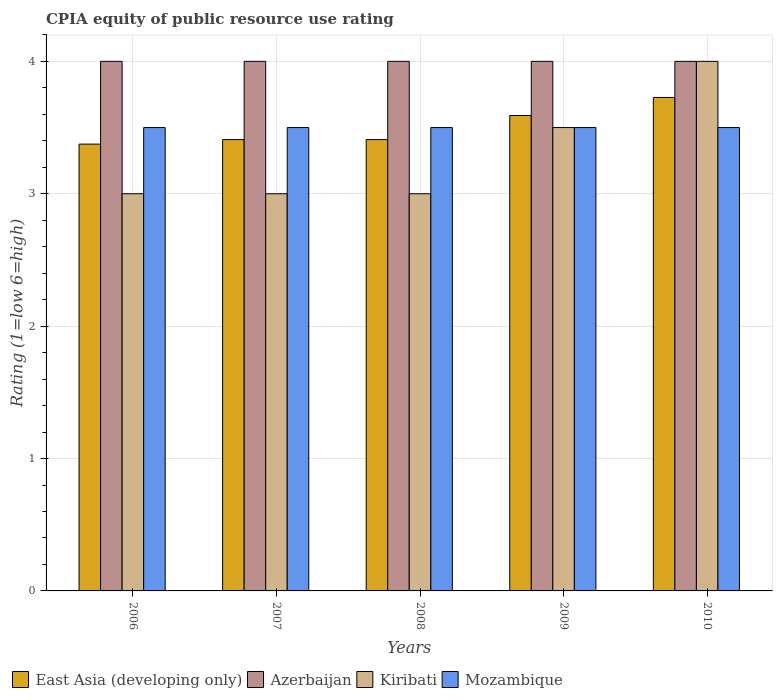How many groups of bars are there?
Give a very brief answer. 5. Are the number of bars per tick equal to the number of legend labels?
Give a very brief answer. Yes. Are the number of bars on each tick of the X-axis equal?
Your answer should be compact. Yes. How many bars are there on the 5th tick from the right?
Give a very brief answer. 4. Across all years, what is the maximum CPIA rating in East Asia (developing only)?
Offer a very short reply. 3.73. Across all years, what is the minimum CPIA rating in Azerbaijan?
Offer a very short reply. 4. In which year was the CPIA rating in East Asia (developing only) maximum?
Your answer should be compact. 2010. What is the total CPIA rating in East Asia (developing only) in the graph?
Ensure brevity in your answer.  17.51. What is the average CPIA rating in Azerbaijan per year?
Keep it short and to the point. 4. In the year 2009, what is the difference between the CPIA rating in East Asia (developing only) and CPIA rating in Mozambique?
Your response must be concise. 0.09. In how many years, is the CPIA rating in Kiribati greater than 2.2?
Make the answer very short. 5. Is the difference between the CPIA rating in East Asia (developing only) in 2008 and 2009 greater than the difference between the CPIA rating in Mozambique in 2008 and 2009?
Provide a short and direct response. No. What is the difference between the highest and the second highest CPIA rating in East Asia (developing only)?
Ensure brevity in your answer.  0.14. What is the difference between the highest and the lowest CPIA rating in Azerbaijan?
Your answer should be very brief. 0. Is the sum of the CPIA rating in Azerbaijan in 2006 and 2007 greater than the maximum CPIA rating in Mozambique across all years?
Offer a terse response. Yes. What does the 2nd bar from the left in 2007 represents?
Your answer should be compact. Azerbaijan. What does the 3rd bar from the right in 2007 represents?
Your answer should be compact. Azerbaijan. Is it the case that in every year, the sum of the CPIA rating in Mozambique and CPIA rating in Kiribati is greater than the CPIA rating in East Asia (developing only)?
Your answer should be compact. Yes. How many years are there in the graph?
Your response must be concise. 5. Does the graph contain grids?
Keep it short and to the point. Yes. Where does the legend appear in the graph?
Give a very brief answer. Bottom left. How are the legend labels stacked?
Provide a succinct answer. Horizontal. What is the title of the graph?
Your answer should be compact. CPIA equity of public resource use rating. Does "South Sudan" appear as one of the legend labels in the graph?
Provide a succinct answer. No. What is the label or title of the X-axis?
Offer a very short reply. Years. What is the label or title of the Y-axis?
Provide a short and direct response. Rating (1=low 6=high). What is the Rating (1=low 6=high) in East Asia (developing only) in 2006?
Your answer should be very brief. 3.38. What is the Rating (1=low 6=high) of Azerbaijan in 2006?
Your answer should be compact. 4. What is the Rating (1=low 6=high) of Kiribati in 2006?
Your response must be concise. 3. What is the Rating (1=low 6=high) in East Asia (developing only) in 2007?
Keep it short and to the point. 3.41. What is the Rating (1=low 6=high) of Azerbaijan in 2007?
Offer a terse response. 4. What is the Rating (1=low 6=high) of Mozambique in 2007?
Offer a terse response. 3.5. What is the Rating (1=low 6=high) in East Asia (developing only) in 2008?
Keep it short and to the point. 3.41. What is the Rating (1=low 6=high) of East Asia (developing only) in 2009?
Offer a very short reply. 3.59. What is the Rating (1=low 6=high) in Azerbaijan in 2009?
Provide a succinct answer. 4. What is the Rating (1=low 6=high) of Kiribati in 2009?
Ensure brevity in your answer.  3.5. What is the Rating (1=low 6=high) of Mozambique in 2009?
Offer a terse response. 3.5. What is the Rating (1=low 6=high) of East Asia (developing only) in 2010?
Ensure brevity in your answer.  3.73. What is the Rating (1=low 6=high) in Azerbaijan in 2010?
Make the answer very short. 4. Across all years, what is the maximum Rating (1=low 6=high) of East Asia (developing only)?
Your answer should be compact. 3.73. Across all years, what is the maximum Rating (1=low 6=high) in Kiribati?
Your response must be concise. 4. Across all years, what is the minimum Rating (1=low 6=high) in East Asia (developing only)?
Ensure brevity in your answer.  3.38. Across all years, what is the minimum Rating (1=low 6=high) of Azerbaijan?
Ensure brevity in your answer.  4. Across all years, what is the minimum Rating (1=low 6=high) of Kiribati?
Your answer should be compact. 3. What is the total Rating (1=low 6=high) in East Asia (developing only) in the graph?
Provide a succinct answer. 17.51. What is the total Rating (1=low 6=high) of Kiribati in the graph?
Your response must be concise. 16.5. What is the difference between the Rating (1=low 6=high) in East Asia (developing only) in 2006 and that in 2007?
Make the answer very short. -0.03. What is the difference between the Rating (1=low 6=high) in East Asia (developing only) in 2006 and that in 2008?
Your answer should be very brief. -0.03. What is the difference between the Rating (1=low 6=high) in East Asia (developing only) in 2006 and that in 2009?
Ensure brevity in your answer.  -0.22. What is the difference between the Rating (1=low 6=high) in Mozambique in 2006 and that in 2009?
Your answer should be very brief. 0. What is the difference between the Rating (1=low 6=high) of East Asia (developing only) in 2006 and that in 2010?
Make the answer very short. -0.35. What is the difference between the Rating (1=low 6=high) in Kiribati in 2006 and that in 2010?
Ensure brevity in your answer.  -1. What is the difference between the Rating (1=low 6=high) in Mozambique in 2006 and that in 2010?
Ensure brevity in your answer.  0. What is the difference between the Rating (1=low 6=high) of East Asia (developing only) in 2007 and that in 2008?
Keep it short and to the point. 0. What is the difference between the Rating (1=low 6=high) of East Asia (developing only) in 2007 and that in 2009?
Give a very brief answer. -0.18. What is the difference between the Rating (1=low 6=high) in Azerbaijan in 2007 and that in 2009?
Keep it short and to the point. 0. What is the difference between the Rating (1=low 6=high) in Kiribati in 2007 and that in 2009?
Provide a short and direct response. -0.5. What is the difference between the Rating (1=low 6=high) of Mozambique in 2007 and that in 2009?
Your answer should be compact. 0. What is the difference between the Rating (1=low 6=high) of East Asia (developing only) in 2007 and that in 2010?
Make the answer very short. -0.32. What is the difference between the Rating (1=low 6=high) in Azerbaijan in 2007 and that in 2010?
Provide a short and direct response. 0. What is the difference between the Rating (1=low 6=high) in Kiribati in 2007 and that in 2010?
Your answer should be compact. -1. What is the difference between the Rating (1=low 6=high) in Mozambique in 2007 and that in 2010?
Make the answer very short. 0. What is the difference between the Rating (1=low 6=high) of East Asia (developing only) in 2008 and that in 2009?
Give a very brief answer. -0.18. What is the difference between the Rating (1=low 6=high) in Mozambique in 2008 and that in 2009?
Make the answer very short. 0. What is the difference between the Rating (1=low 6=high) in East Asia (developing only) in 2008 and that in 2010?
Ensure brevity in your answer.  -0.32. What is the difference between the Rating (1=low 6=high) in Mozambique in 2008 and that in 2010?
Keep it short and to the point. 0. What is the difference between the Rating (1=low 6=high) in East Asia (developing only) in 2009 and that in 2010?
Provide a short and direct response. -0.14. What is the difference between the Rating (1=low 6=high) of Kiribati in 2009 and that in 2010?
Keep it short and to the point. -0.5. What is the difference between the Rating (1=low 6=high) in East Asia (developing only) in 2006 and the Rating (1=low 6=high) in Azerbaijan in 2007?
Provide a succinct answer. -0.62. What is the difference between the Rating (1=low 6=high) in East Asia (developing only) in 2006 and the Rating (1=low 6=high) in Kiribati in 2007?
Keep it short and to the point. 0.38. What is the difference between the Rating (1=low 6=high) in East Asia (developing only) in 2006 and the Rating (1=low 6=high) in Mozambique in 2007?
Provide a succinct answer. -0.12. What is the difference between the Rating (1=low 6=high) of Azerbaijan in 2006 and the Rating (1=low 6=high) of Mozambique in 2007?
Your answer should be compact. 0.5. What is the difference between the Rating (1=low 6=high) of East Asia (developing only) in 2006 and the Rating (1=low 6=high) of Azerbaijan in 2008?
Give a very brief answer. -0.62. What is the difference between the Rating (1=low 6=high) in East Asia (developing only) in 2006 and the Rating (1=low 6=high) in Mozambique in 2008?
Your response must be concise. -0.12. What is the difference between the Rating (1=low 6=high) in Kiribati in 2006 and the Rating (1=low 6=high) in Mozambique in 2008?
Keep it short and to the point. -0.5. What is the difference between the Rating (1=low 6=high) of East Asia (developing only) in 2006 and the Rating (1=low 6=high) of Azerbaijan in 2009?
Provide a succinct answer. -0.62. What is the difference between the Rating (1=low 6=high) of East Asia (developing only) in 2006 and the Rating (1=low 6=high) of Kiribati in 2009?
Give a very brief answer. -0.12. What is the difference between the Rating (1=low 6=high) in East Asia (developing only) in 2006 and the Rating (1=low 6=high) in Mozambique in 2009?
Provide a short and direct response. -0.12. What is the difference between the Rating (1=low 6=high) in Azerbaijan in 2006 and the Rating (1=low 6=high) in Kiribati in 2009?
Keep it short and to the point. 0.5. What is the difference between the Rating (1=low 6=high) in Azerbaijan in 2006 and the Rating (1=low 6=high) in Mozambique in 2009?
Offer a very short reply. 0.5. What is the difference between the Rating (1=low 6=high) in East Asia (developing only) in 2006 and the Rating (1=low 6=high) in Azerbaijan in 2010?
Your response must be concise. -0.62. What is the difference between the Rating (1=low 6=high) in East Asia (developing only) in 2006 and the Rating (1=low 6=high) in Kiribati in 2010?
Offer a terse response. -0.62. What is the difference between the Rating (1=low 6=high) of East Asia (developing only) in 2006 and the Rating (1=low 6=high) of Mozambique in 2010?
Your answer should be compact. -0.12. What is the difference between the Rating (1=low 6=high) of East Asia (developing only) in 2007 and the Rating (1=low 6=high) of Azerbaijan in 2008?
Your answer should be compact. -0.59. What is the difference between the Rating (1=low 6=high) of East Asia (developing only) in 2007 and the Rating (1=low 6=high) of Kiribati in 2008?
Ensure brevity in your answer.  0.41. What is the difference between the Rating (1=low 6=high) in East Asia (developing only) in 2007 and the Rating (1=low 6=high) in Mozambique in 2008?
Ensure brevity in your answer.  -0.09. What is the difference between the Rating (1=low 6=high) in Azerbaijan in 2007 and the Rating (1=low 6=high) in Kiribati in 2008?
Provide a succinct answer. 1. What is the difference between the Rating (1=low 6=high) of Kiribati in 2007 and the Rating (1=low 6=high) of Mozambique in 2008?
Make the answer very short. -0.5. What is the difference between the Rating (1=low 6=high) of East Asia (developing only) in 2007 and the Rating (1=low 6=high) of Azerbaijan in 2009?
Your answer should be very brief. -0.59. What is the difference between the Rating (1=low 6=high) of East Asia (developing only) in 2007 and the Rating (1=low 6=high) of Kiribati in 2009?
Keep it short and to the point. -0.09. What is the difference between the Rating (1=low 6=high) of East Asia (developing only) in 2007 and the Rating (1=low 6=high) of Mozambique in 2009?
Provide a short and direct response. -0.09. What is the difference between the Rating (1=low 6=high) of Azerbaijan in 2007 and the Rating (1=low 6=high) of Kiribati in 2009?
Ensure brevity in your answer.  0.5. What is the difference between the Rating (1=low 6=high) in Kiribati in 2007 and the Rating (1=low 6=high) in Mozambique in 2009?
Ensure brevity in your answer.  -0.5. What is the difference between the Rating (1=low 6=high) in East Asia (developing only) in 2007 and the Rating (1=low 6=high) in Azerbaijan in 2010?
Keep it short and to the point. -0.59. What is the difference between the Rating (1=low 6=high) in East Asia (developing only) in 2007 and the Rating (1=low 6=high) in Kiribati in 2010?
Your response must be concise. -0.59. What is the difference between the Rating (1=low 6=high) in East Asia (developing only) in 2007 and the Rating (1=low 6=high) in Mozambique in 2010?
Offer a very short reply. -0.09. What is the difference between the Rating (1=low 6=high) of Kiribati in 2007 and the Rating (1=low 6=high) of Mozambique in 2010?
Provide a short and direct response. -0.5. What is the difference between the Rating (1=low 6=high) of East Asia (developing only) in 2008 and the Rating (1=low 6=high) of Azerbaijan in 2009?
Ensure brevity in your answer.  -0.59. What is the difference between the Rating (1=low 6=high) of East Asia (developing only) in 2008 and the Rating (1=low 6=high) of Kiribati in 2009?
Offer a terse response. -0.09. What is the difference between the Rating (1=low 6=high) of East Asia (developing only) in 2008 and the Rating (1=low 6=high) of Mozambique in 2009?
Make the answer very short. -0.09. What is the difference between the Rating (1=low 6=high) of Kiribati in 2008 and the Rating (1=low 6=high) of Mozambique in 2009?
Offer a very short reply. -0.5. What is the difference between the Rating (1=low 6=high) of East Asia (developing only) in 2008 and the Rating (1=low 6=high) of Azerbaijan in 2010?
Offer a terse response. -0.59. What is the difference between the Rating (1=low 6=high) in East Asia (developing only) in 2008 and the Rating (1=low 6=high) in Kiribati in 2010?
Provide a short and direct response. -0.59. What is the difference between the Rating (1=low 6=high) of East Asia (developing only) in 2008 and the Rating (1=low 6=high) of Mozambique in 2010?
Your response must be concise. -0.09. What is the difference between the Rating (1=low 6=high) of Azerbaijan in 2008 and the Rating (1=low 6=high) of Mozambique in 2010?
Offer a terse response. 0.5. What is the difference between the Rating (1=low 6=high) in East Asia (developing only) in 2009 and the Rating (1=low 6=high) in Azerbaijan in 2010?
Ensure brevity in your answer.  -0.41. What is the difference between the Rating (1=low 6=high) in East Asia (developing only) in 2009 and the Rating (1=low 6=high) in Kiribati in 2010?
Your answer should be compact. -0.41. What is the difference between the Rating (1=low 6=high) in East Asia (developing only) in 2009 and the Rating (1=low 6=high) in Mozambique in 2010?
Provide a succinct answer. 0.09. What is the difference between the Rating (1=low 6=high) of Azerbaijan in 2009 and the Rating (1=low 6=high) of Kiribati in 2010?
Offer a terse response. 0. What is the average Rating (1=low 6=high) of East Asia (developing only) per year?
Provide a succinct answer. 3.5. What is the average Rating (1=low 6=high) of Kiribati per year?
Keep it short and to the point. 3.3. In the year 2006, what is the difference between the Rating (1=low 6=high) in East Asia (developing only) and Rating (1=low 6=high) in Azerbaijan?
Give a very brief answer. -0.62. In the year 2006, what is the difference between the Rating (1=low 6=high) of East Asia (developing only) and Rating (1=low 6=high) of Kiribati?
Keep it short and to the point. 0.38. In the year 2006, what is the difference between the Rating (1=low 6=high) in East Asia (developing only) and Rating (1=low 6=high) in Mozambique?
Offer a terse response. -0.12. In the year 2006, what is the difference between the Rating (1=low 6=high) of Azerbaijan and Rating (1=low 6=high) of Kiribati?
Ensure brevity in your answer.  1. In the year 2006, what is the difference between the Rating (1=low 6=high) of Azerbaijan and Rating (1=low 6=high) of Mozambique?
Give a very brief answer. 0.5. In the year 2007, what is the difference between the Rating (1=low 6=high) of East Asia (developing only) and Rating (1=low 6=high) of Azerbaijan?
Offer a terse response. -0.59. In the year 2007, what is the difference between the Rating (1=low 6=high) of East Asia (developing only) and Rating (1=low 6=high) of Kiribati?
Your response must be concise. 0.41. In the year 2007, what is the difference between the Rating (1=low 6=high) in East Asia (developing only) and Rating (1=low 6=high) in Mozambique?
Provide a short and direct response. -0.09. In the year 2007, what is the difference between the Rating (1=low 6=high) in Azerbaijan and Rating (1=low 6=high) in Kiribati?
Your answer should be very brief. 1. In the year 2007, what is the difference between the Rating (1=low 6=high) of Azerbaijan and Rating (1=low 6=high) of Mozambique?
Your answer should be compact. 0.5. In the year 2007, what is the difference between the Rating (1=low 6=high) of Kiribati and Rating (1=low 6=high) of Mozambique?
Keep it short and to the point. -0.5. In the year 2008, what is the difference between the Rating (1=low 6=high) in East Asia (developing only) and Rating (1=low 6=high) in Azerbaijan?
Your answer should be very brief. -0.59. In the year 2008, what is the difference between the Rating (1=low 6=high) of East Asia (developing only) and Rating (1=low 6=high) of Kiribati?
Give a very brief answer. 0.41. In the year 2008, what is the difference between the Rating (1=low 6=high) of East Asia (developing only) and Rating (1=low 6=high) of Mozambique?
Offer a very short reply. -0.09. In the year 2008, what is the difference between the Rating (1=low 6=high) in Azerbaijan and Rating (1=low 6=high) in Kiribati?
Offer a very short reply. 1. In the year 2009, what is the difference between the Rating (1=low 6=high) in East Asia (developing only) and Rating (1=low 6=high) in Azerbaijan?
Ensure brevity in your answer.  -0.41. In the year 2009, what is the difference between the Rating (1=low 6=high) in East Asia (developing only) and Rating (1=low 6=high) in Kiribati?
Ensure brevity in your answer.  0.09. In the year 2009, what is the difference between the Rating (1=low 6=high) in East Asia (developing only) and Rating (1=low 6=high) in Mozambique?
Your answer should be very brief. 0.09. In the year 2009, what is the difference between the Rating (1=low 6=high) in Azerbaijan and Rating (1=low 6=high) in Kiribati?
Provide a short and direct response. 0.5. In the year 2009, what is the difference between the Rating (1=low 6=high) in Azerbaijan and Rating (1=low 6=high) in Mozambique?
Keep it short and to the point. 0.5. In the year 2009, what is the difference between the Rating (1=low 6=high) in Kiribati and Rating (1=low 6=high) in Mozambique?
Keep it short and to the point. 0. In the year 2010, what is the difference between the Rating (1=low 6=high) in East Asia (developing only) and Rating (1=low 6=high) in Azerbaijan?
Offer a terse response. -0.27. In the year 2010, what is the difference between the Rating (1=low 6=high) of East Asia (developing only) and Rating (1=low 6=high) of Kiribati?
Your answer should be compact. -0.27. In the year 2010, what is the difference between the Rating (1=low 6=high) in East Asia (developing only) and Rating (1=low 6=high) in Mozambique?
Offer a very short reply. 0.23. In the year 2010, what is the difference between the Rating (1=low 6=high) of Azerbaijan and Rating (1=low 6=high) of Kiribati?
Your response must be concise. 0. In the year 2010, what is the difference between the Rating (1=low 6=high) in Azerbaijan and Rating (1=low 6=high) in Mozambique?
Your answer should be compact. 0.5. In the year 2010, what is the difference between the Rating (1=low 6=high) in Kiribati and Rating (1=low 6=high) in Mozambique?
Provide a succinct answer. 0.5. What is the ratio of the Rating (1=low 6=high) in East Asia (developing only) in 2006 to that in 2007?
Provide a succinct answer. 0.99. What is the ratio of the Rating (1=low 6=high) of Mozambique in 2006 to that in 2007?
Offer a terse response. 1. What is the ratio of the Rating (1=low 6=high) in East Asia (developing only) in 2006 to that in 2008?
Offer a very short reply. 0.99. What is the ratio of the Rating (1=low 6=high) of Azerbaijan in 2006 to that in 2008?
Provide a short and direct response. 1. What is the ratio of the Rating (1=low 6=high) in Kiribati in 2006 to that in 2008?
Make the answer very short. 1. What is the ratio of the Rating (1=low 6=high) of Mozambique in 2006 to that in 2008?
Offer a very short reply. 1. What is the ratio of the Rating (1=low 6=high) of East Asia (developing only) in 2006 to that in 2009?
Give a very brief answer. 0.94. What is the ratio of the Rating (1=low 6=high) in Kiribati in 2006 to that in 2009?
Your answer should be very brief. 0.86. What is the ratio of the Rating (1=low 6=high) of Mozambique in 2006 to that in 2009?
Your answer should be very brief. 1. What is the ratio of the Rating (1=low 6=high) of East Asia (developing only) in 2006 to that in 2010?
Keep it short and to the point. 0.91. What is the ratio of the Rating (1=low 6=high) of Kiribati in 2006 to that in 2010?
Your answer should be compact. 0.75. What is the ratio of the Rating (1=low 6=high) of Mozambique in 2006 to that in 2010?
Keep it short and to the point. 1. What is the ratio of the Rating (1=low 6=high) of East Asia (developing only) in 2007 to that in 2008?
Your answer should be very brief. 1. What is the ratio of the Rating (1=low 6=high) of East Asia (developing only) in 2007 to that in 2009?
Your answer should be compact. 0.95. What is the ratio of the Rating (1=low 6=high) in Azerbaijan in 2007 to that in 2009?
Your answer should be compact. 1. What is the ratio of the Rating (1=low 6=high) of Mozambique in 2007 to that in 2009?
Your response must be concise. 1. What is the ratio of the Rating (1=low 6=high) of East Asia (developing only) in 2007 to that in 2010?
Offer a terse response. 0.91. What is the ratio of the Rating (1=low 6=high) in Mozambique in 2007 to that in 2010?
Your answer should be very brief. 1. What is the ratio of the Rating (1=low 6=high) in East Asia (developing only) in 2008 to that in 2009?
Your response must be concise. 0.95. What is the ratio of the Rating (1=low 6=high) of East Asia (developing only) in 2008 to that in 2010?
Offer a terse response. 0.91. What is the ratio of the Rating (1=low 6=high) in Azerbaijan in 2008 to that in 2010?
Provide a short and direct response. 1. What is the ratio of the Rating (1=low 6=high) of East Asia (developing only) in 2009 to that in 2010?
Your answer should be very brief. 0.96. What is the ratio of the Rating (1=low 6=high) of Azerbaijan in 2009 to that in 2010?
Keep it short and to the point. 1. What is the difference between the highest and the second highest Rating (1=low 6=high) of East Asia (developing only)?
Your answer should be compact. 0.14. What is the difference between the highest and the second highest Rating (1=low 6=high) in Azerbaijan?
Ensure brevity in your answer.  0. What is the difference between the highest and the second highest Rating (1=low 6=high) in Kiribati?
Offer a very short reply. 0.5. What is the difference between the highest and the lowest Rating (1=low 6=high) in East Asia (developing only)?
Ensure brevity in your answer.  0.35. What is the difference between the highest and the lowest Rating (1=low 6=high) of Azerbaijan?
Keep it short and to the point. 0. What is the difference between the highest and the lowest Rating (1=low 6=high) of Mozambique?
Your answer should be very brief. 0. 